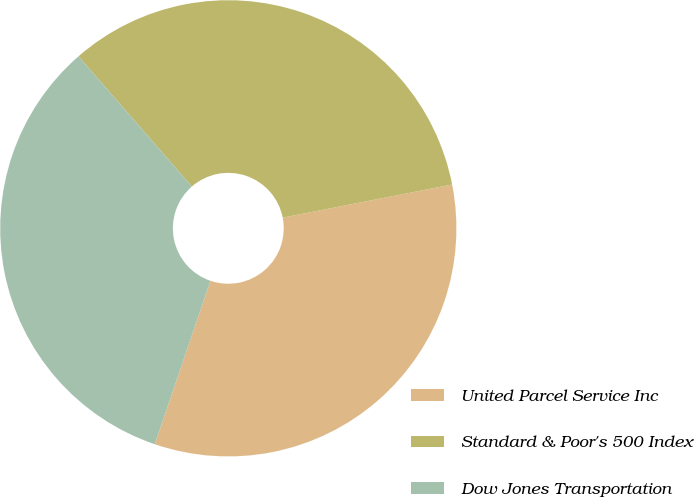Convert chart to OTSL. <chart><loc_0><loc_0><loc_500><loc_500><pie_chart><fcel>United Parcel Service Inc<fcel>Standard & Poor's 500 Index<fcel>Dow Jones Transportation<nl><fcel>33.3%<fcel>33.33%<fcel>33.37%<nl></chart> 